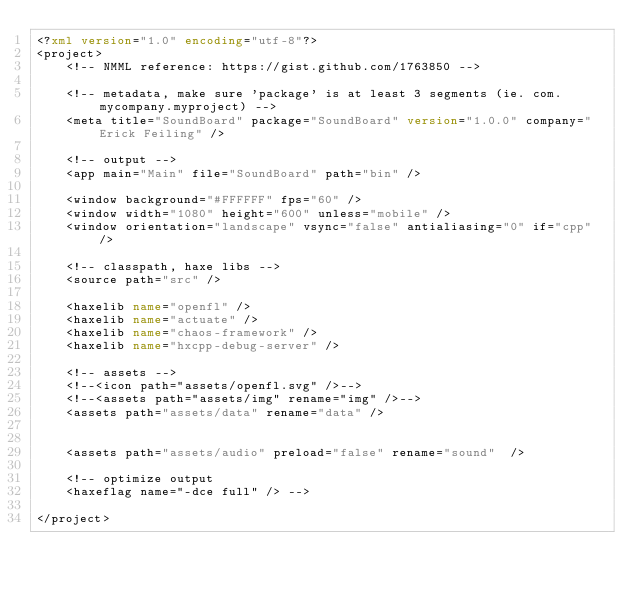Convert code to text. <code><loc_0><loc_0><loc_500><loc_500><_XML_><?xml version="1.0" encoding="utf-8"?>
<project>
	<!-- NMML reference: https://gist.github.com/1763850 -->
	
	<!-- metadata, make sure 'package' is at least 3 segments (ie. com.mycompany.myproject) -->
	<meta title="SoundBoard" package="SoundBoard" version="1.0.0" company="Erick Feiling" />
	
	<!-- output -->
	<app main="Main" file="SoundBoard" path="bin" />
	
	<window background="#FFFFFF" fps="60" />
	<window width="1080" height="600" unless="mobile" />
	<window orientation="landscape" vsync="false" antialiasing="0" if="cpp" />
	
	<!-- classpath, haxe libs --> 
	<source path="src" />
	
	<haxelib name="openfl" />
	<haxelib name="actuate" />
	<haxelib name="chaos-framework" />
	<haxelib name="hxcpp-debug-server" /> 
	
	<!-- assets -->
	<!--<icon path="assets/openfl.svg" />-->
	<!--<assets path="assets/img" rename="img" />-->
	<assets path="assets/data" rename="data" />


	<assets path="assets/audio" preload="false" rename="sound"  />
	
	<!-- optimize output
	<haxeflag name="-dce full" /> -->
	
</project></code> 